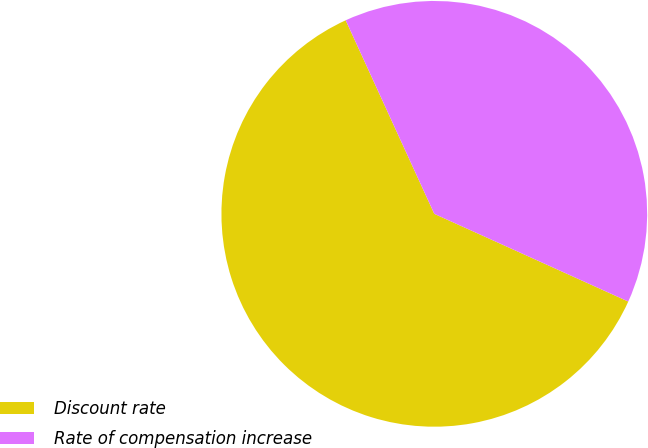Convert chart. <chart><loc_0><loc_0><loc_500><loc_500><pie_chart><fcel>Discount rate<fcel>Rate of compensation increase<nl><fcel>61.41%<fcel>38.59%<nl></chart> 